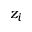Convert formula to latex. <formula><loc_0><loc_0><loc_500><loc_500>z _ { i }</formula> 